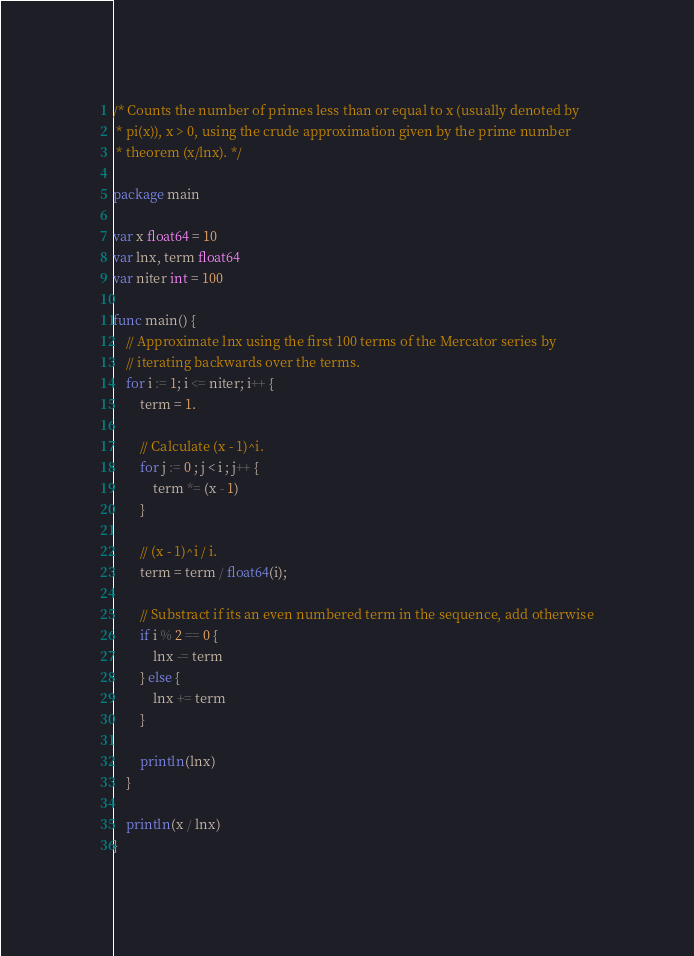<code> <loc_0><loc_0><loc_500><loc_500><_Go_>/* Counts the number of primes less than or equal to x (usually denoted by
 * pi(x)), x > 0, using the crude approximation given by the prime number
 * theorem (x/lnx). */

package main

var x float64 = 10
var lnx, term float64
var niter int = 100

func main() {
	// Approximate lnx using the first 100 terms of the Mercator series by
	// iterating backwards over the terms.
	for i := 1; i <= niter; i++ {
		term = 1.

		// Calculate (x - 1)^i.
		for j := 0 ; j < i ; j++ {
			term *= (x - 1)
		}

		// (x - 1)^i / i.
		term = term / float64(i);

		// Substract if its an even numbered term in the sequence, add otherwise
		if i % 2 == 0 {
			lnx -= term
		} else {
			lnx += term
		}
		
		println(lnx)
	}

	println(x / lnx)
}
</code> 